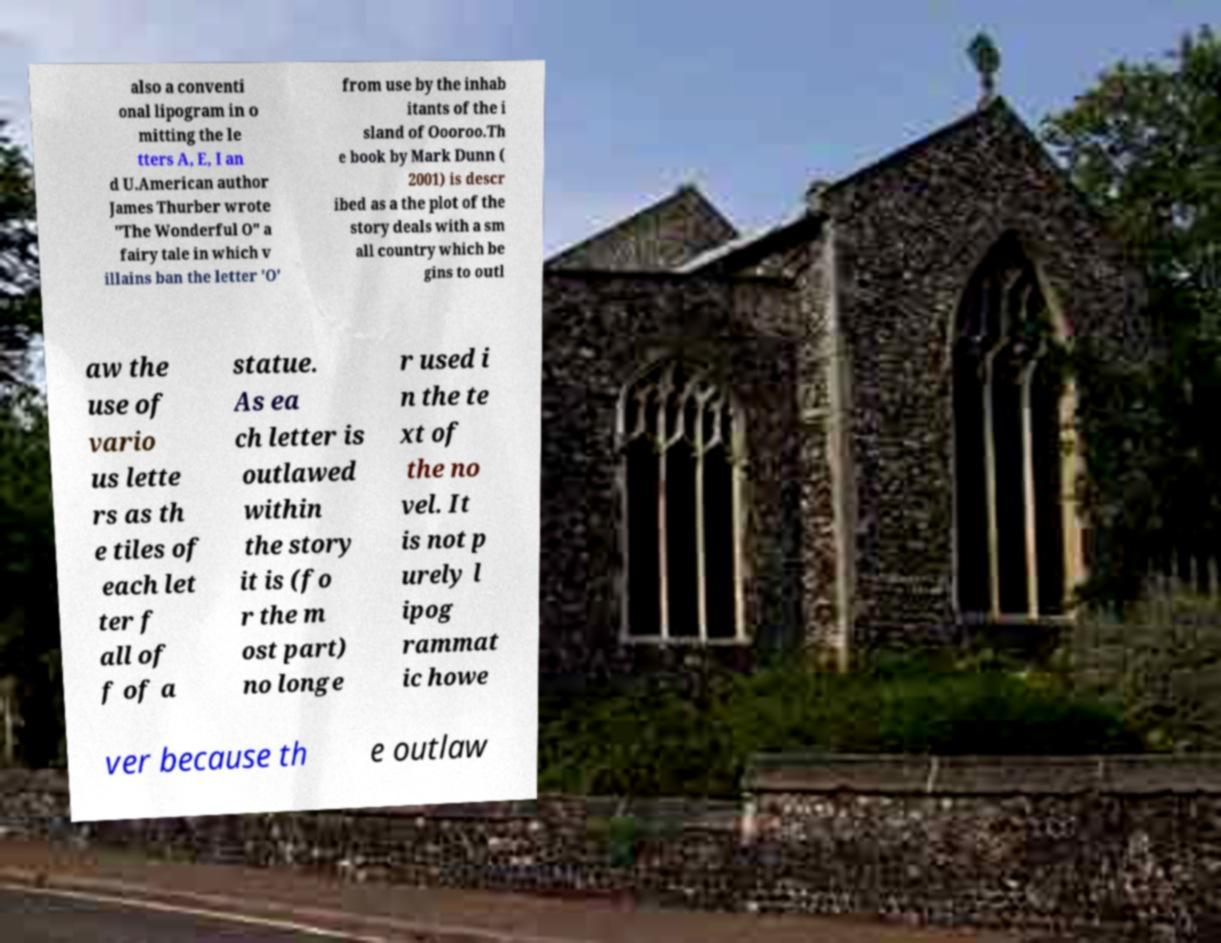Please read and relay the text visible in this image. What does it say? also a conventi onal lipogram in o mitting the le tters A, E, I an d U.American author James Thurber wrote "The Wonderful O" a fairy tale in which v illains ban the letter 'O' from use by the inhab itants of the i sland of Oooroo.Th e book by Mark Dunn ( 2001) is descr ibed as a the plot of the story deals with a sm all country which be gins to outl aw the use of vario us lette rs as th e tiles of each let ter f all of f of a statue. As ea ch letter is outlawed within the story it is (fo r the m ost part) no longe r used i n the te xt of the no vel. It is not p urely l ipog rammat ic howe ver because th e outlaw 